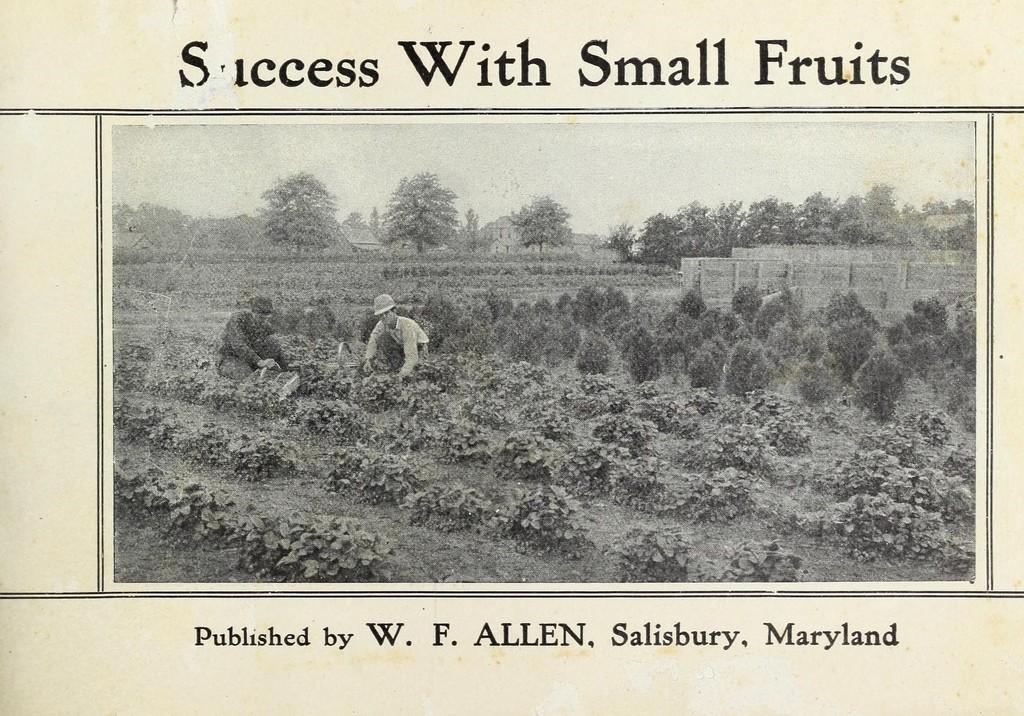Could you give a brief overview of what you see in this image? This is a black and white picture. In this picture, we see two people are planting plants. In front of them, we see field crops. Behind them, we see the plants. There are trees and buildings in the background. At the top and at the bottom of the picture, we see some text written. This picture might be taken from the textbook. 